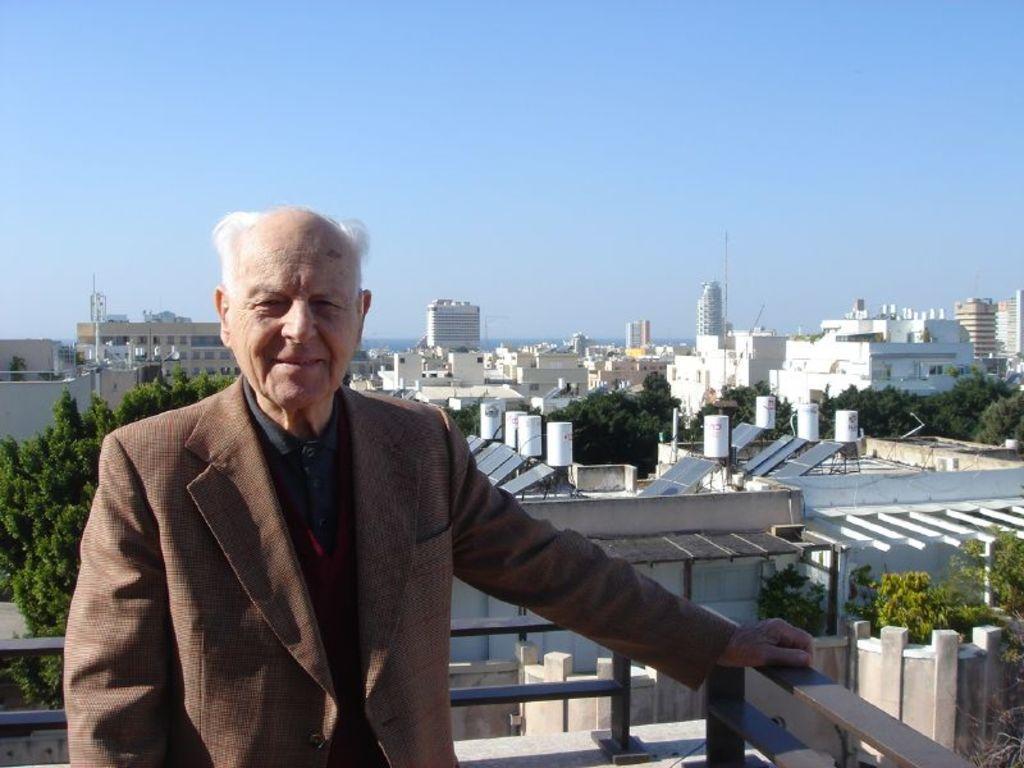Please provide a concise description of this image. In this image a person is standing on a rooftop and holding a railing, behind him there are building, solar panels, polls and trees. 